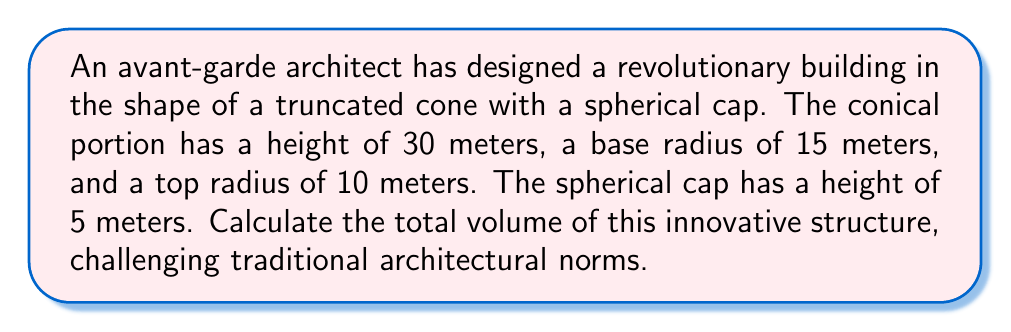Give your solution to this math problem. To solve this problem, we need to calculate the volume of the truncated cone and the spherical cap separately, then add them together.

Step 1: Calculate the volume of the truncated cone
The formula for the volume of a truncated cone is:
$$V_{cone} = \frac{1}{3}\pi h(R^2 + r^2 + Rr)$$
Where $h$ is the height, $R$ is the radius of the base, and $r$ is the radius of the top.

Substituting the given values:
$$V_{cone} = \frac{1}{3}\pi \cdot 30(15^2 + 10^2 + 15 \cdot 10)$$
$$V_{cone} = 10\pi(225 + 100 + 150)$$
$$V_{cone} = 4750\pi$$

Step 2: Calculate the volume of the spherical cap
First, we need to find the radius of the sphere. Let $R$ be the radius of the sphere and $r$ be the radius of the base of the cap (which is the same as the top radius of the cone). The formula relating these is:
$$R^2 = h^2 + r^2$$
Where $h$ is the height of the cap.

Substituting the values:
$$R^2 = 5^2 + 10^2 = 125$$
$$R = \sqrt{125} = 5\sqrt{5}$$

Now we can use the formula for the volume of a spherical cap:
$$V_{cap} = \frac{1}{3}\pi h^2(3R - h)$$

Substituting the values:
$$V_{cap} = \frac{1}{3}\pi \cdot 5^2(3 \cdot 5\sqrt{5} - 5)$$
$$V_{cap} = \frac{25\pi}{3}(15\sqrt{5} - 5)$$

Step 3: Calculate the total volume
Total volume = Volume of truncated cone + Volume of spherical cap
$$V_{total} = 4750\pi + \frac{25\pi}{3}(15\sqrt{5} - 5)$$
$$V_{total} = \pi(4750 + \frac{25}{3}(15\sqrt{5} - 5))$$
Answer: $\pi(4750 + \frac{25}{3}(15\sqrt{5} - 5))$ cubic meters 